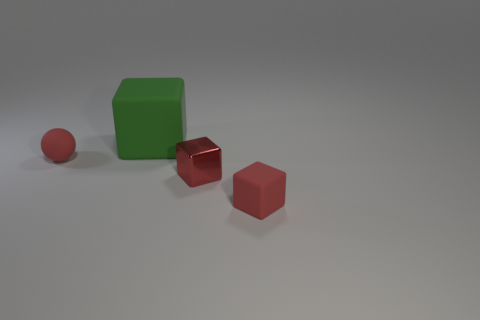There is another cube that is the same size as the red matte cube; what material is it? The cube that is the same size as the red matte cube appears to be made of a green matte material, exhibiting a similar lack of shine or reflection, indicating it does not have a metallic surface. 